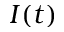Convert formula to latex. <formula><loc_0><loc_0><loc_500><loc_500>I ( t )</formula> 